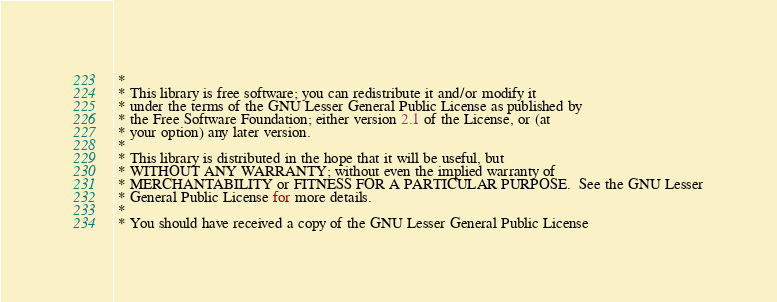<code> <loc_0><loc_0><loc_500><loc_500><_Java_> * 
 * This library is free software; you can redistribute it and/or modify it
 * under the terms of the GNU Lesser General Public License as published by
 * the Free Software Foundation; either version 2.1 of the License, or (at
 * your option) any later version.
 * 
 * This library is distributed in the hope that it will be useful, but
 * WITHOUT ANY WARRANTY; without even the implied warranty of
 * MERCHANTABILITY or FITNESS FOR A PARTICULAR PURPOSE.  See the GNU Lesser
 * General Public License for more details.
 * 
 * You should have received a copy of the GNU Lesser General Public License</code> 